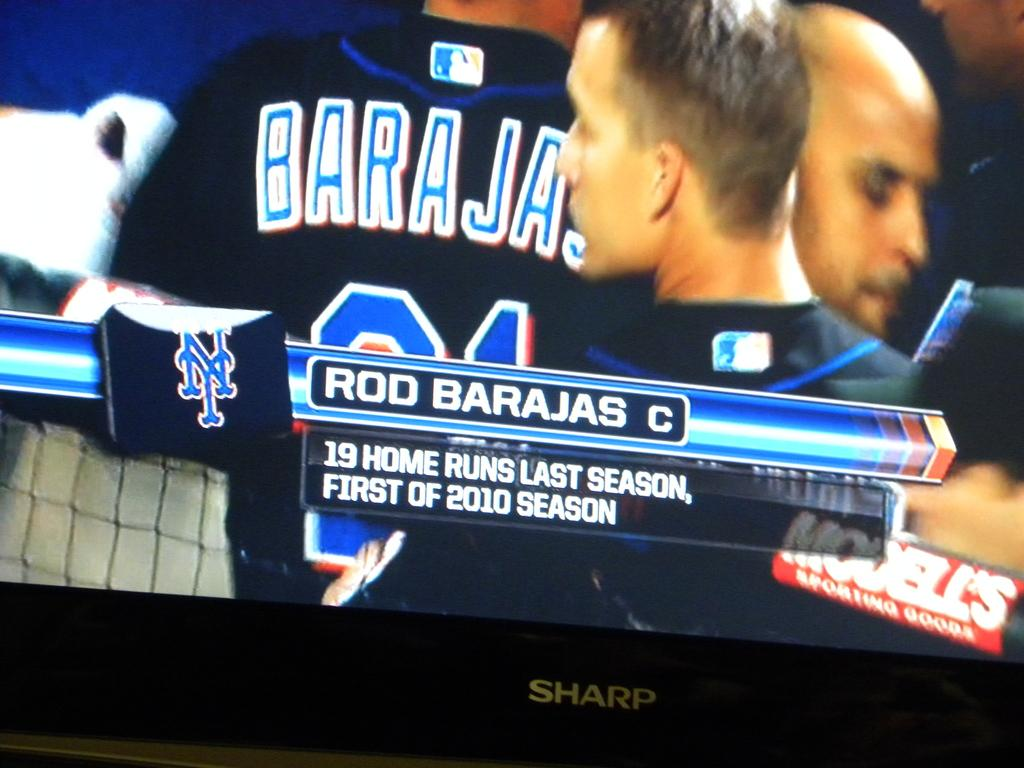<image>
Write a terse but informative summary of the picture. A Sharp brand tv shows a baseball game. 